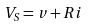<formula> <loc_0><loc_0><loc_500><loc_500>V _ { S } = v + R i</formula> 